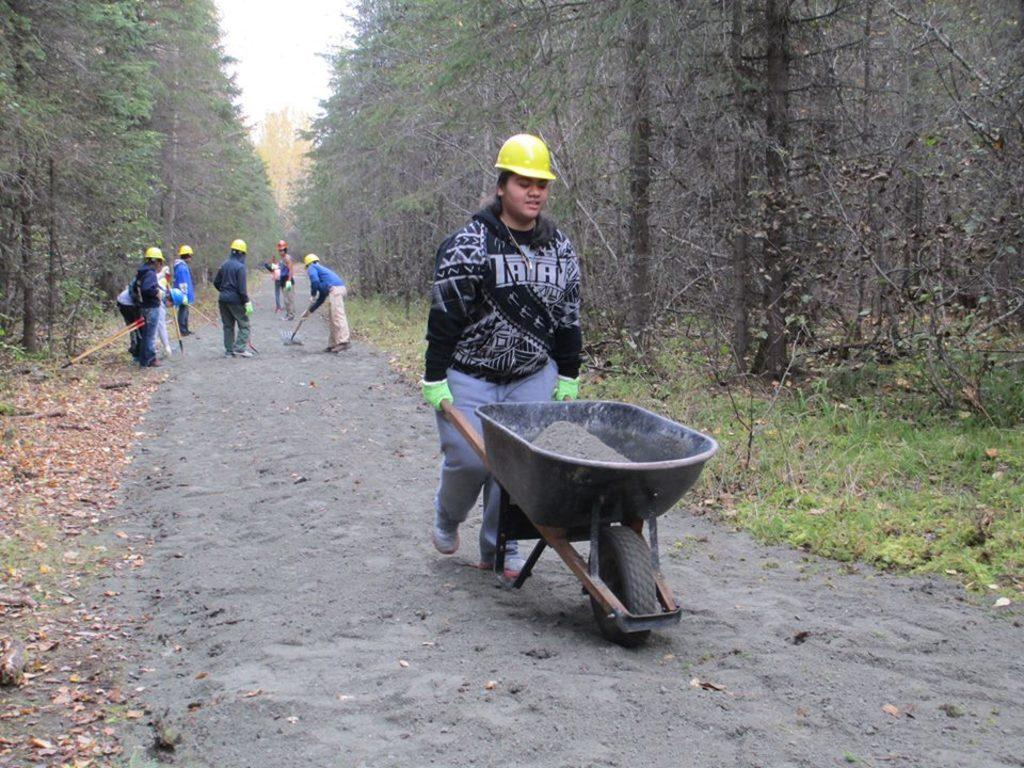What activity is taking place in the image? There are people working on a cement road in the image. Can you describe the action of one of the workers? A person is carrying a cement in a trolley. What type of vegetation can be seen in the image? There are trees on both sides of the image. How many pigs are running in the direction of the trees in the image? There are no pigs present in the image, and therefore no such activity can be observed. 